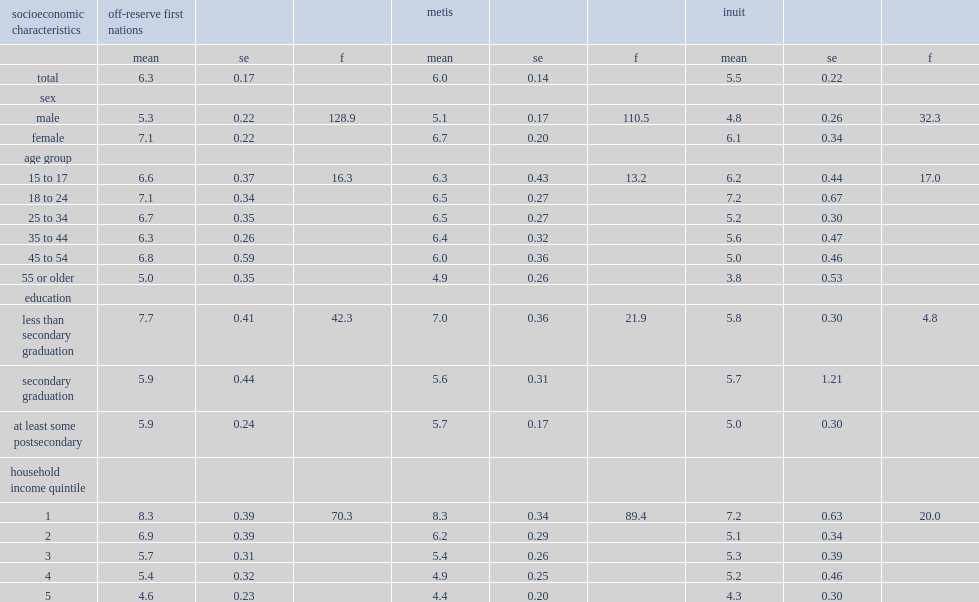What was the mean k10 score (range 0 to 40) for first nations people living off reserve? 6.3. What was the mean k10 score (range 0 to 40) for metis people living off reserve? 6.0. What was the mean k10 score (range 0 to 40) for inuit people living off reserve? 5.5. Can you give me this table as a dict? {'header': ['socioeconomic characteristics', 'off-reserve first nations', '', '', 'metis', '', '', 'inuit', '', ''], 'rows': [['', 'mean', 'se', 'f', 'mean', 'se', 'f', 'mean', 'se', 'f'], ['total', '6.3', '0.17', '', '6.0', '0.14', '', '5.5', '0.22', ''], ['sex', '', '', '', '', '', '', '', '', ''], ['male', '5.3', '0.22', '128.9', '5.1', '0.17', '110.5', '4.8', '0.26', '32.3'], ['female', '7.1', '0.22', '', '6.7', '0.20', '', '6.1', '0.34', ''], ['age group', '', '', '', '', '', '', '', '', ''], ['15 to 17', '6.6', '0.37', '16.3', '6.3', '0.43', '13.2', '6.2', '0.44', '17.0'], ['18 to 24', '7.1', '0.34', '', '6.5', '0.27', '', '7.2', '0.67', ''], ['25 to 34', '6.7', '0.35', '', '6.5', '0.27', '', '5.2', '0.30', ''], ['35 to 44', '6.3', '0.26', '', '6.4', '0.32', '', '5.6', '0.47', ''], ['45 to 54', '6.8', '0.59', '', '6.0', '0.36', '', '5.0', '0.46', ''], ['55 or older', '5.0', '0.35', '', '4.9', '0.26', '', '3.8', '0.53', ''], ['education', '', '', '', '', '', '', '', '', ''], ['less than secondary graduation', '7.7', '0.41', '42.3', '7.0', '0.36', '21.9', '5.8', '0.30', '4.8'], ['secondary graduation', '5.9', '0.44', '', '5.6', '0.31', '', '5.7', '1.21', ''], ['at least some postsecondary', '5.9', '0.24', '', '5.7', '0.17', '', '5.0', '0.30', ''], ['household income quintile', '', '', '', '', '', '', '', '', ''], ['1', '8.3', '0.39', '70.3', '8.3', '0.34', '89.4', '7.2', '0.63', '20.0'], ['2', '6.9', '0.39', '', '6.2', '0.29', '', '5.1', '0.34', ''], ['3', '5.7', '0.31', '', '5.4', '0.26', '', '5.3', '0.39', ''], ['4', '5.4', '0.32', '', '4.9', '0.25', '', '5.2', '0.46', ''], ['5', '4.6', '0.23', '', '4.4', '0.20', '', '4.3', '0.30', '']]} 